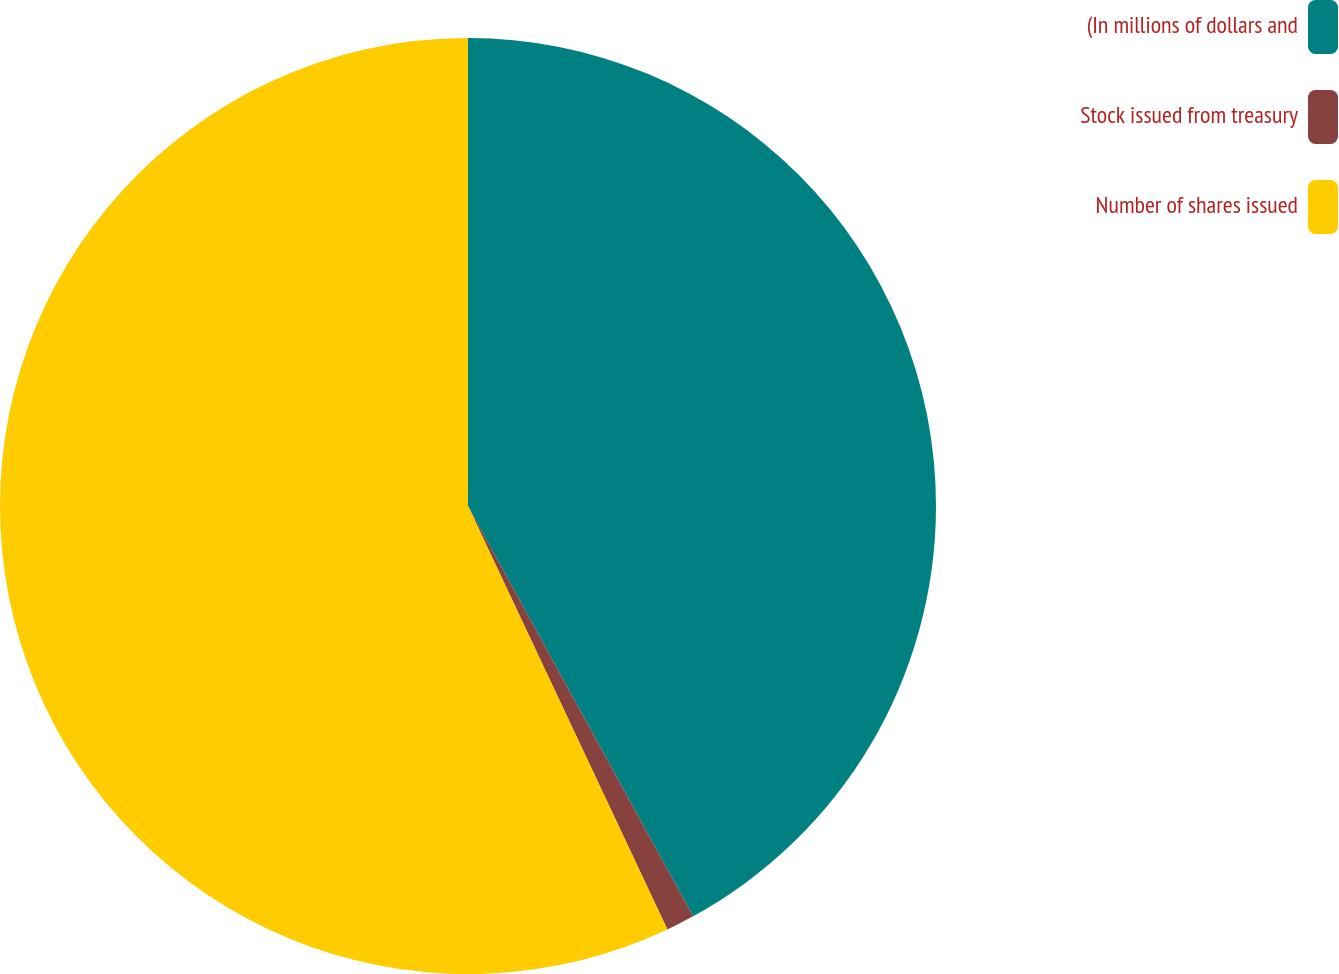<chart> <loc_0><loc_0><loc_500><loc_500><pie_chart><fcel>(In millions of dollars and<fcel>Stock issued from treasury<fcel>Number of shares issued<nl><fcel>42.01%<fcel>0.98%<fcel>57.0%<nl></chart> 